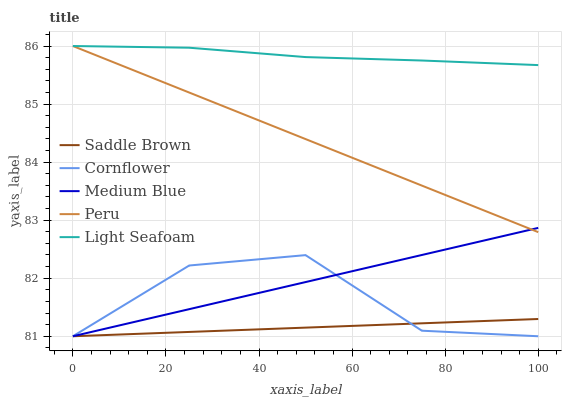Does Saddle Brown have the minimum area under the curve?
Answer yes or no. Yes. Does Light Seafoam have the maximum area under the curve?
Answer yes or no. Yes. Does Medium Blue have the minimum area under the curve?
Answer yes or no. No. Does Medium Blue have the maximum area under the curve?
Answer yes or no. No. Is Saddle Brown the smoothest?
Answer yes or no. Yes. Is Cornflower the roughest?
Answer yes or no. Yes. Is Light Seafoam the smoothest?
Answer yes or no. No. Is Light Seafoam the roughest?
Answer yes or no. No. Does Light Seafoam have the lowest value?
Answer yes or no. No. Does Medium Blue have the highest value?
Answer yes or no. No. Is Cornflower less than Light Seafoam?
Answer yes or no. Yes. Is Light Seafoam greater than Saddle Brown?
Answer yes or no. Yes. Does Cornflower intersect Light Seafoam?
Answer yes or no. No. 